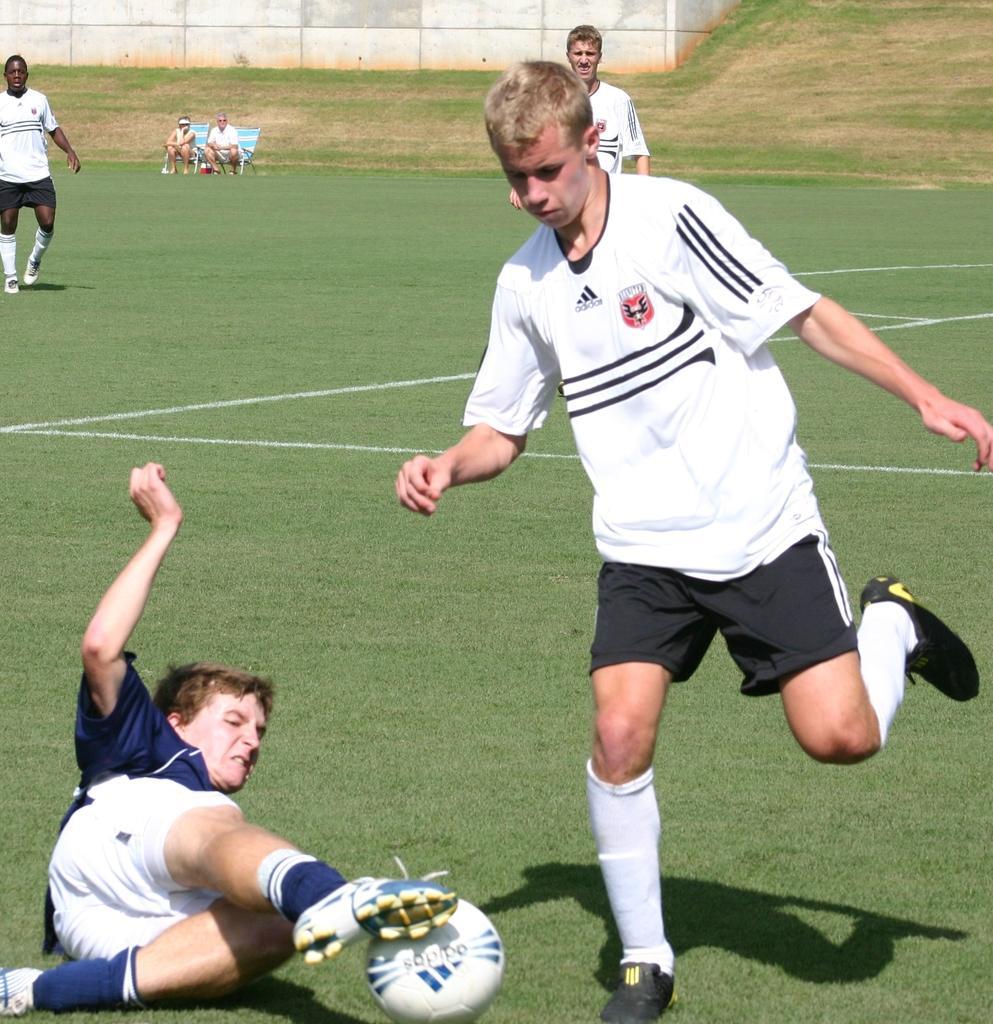How would you summarize this image in a sentence or two? Two people sitting in chairs and watching a football game. In which, a player is trying to kick the ball and the other is slipped on to the ball. 